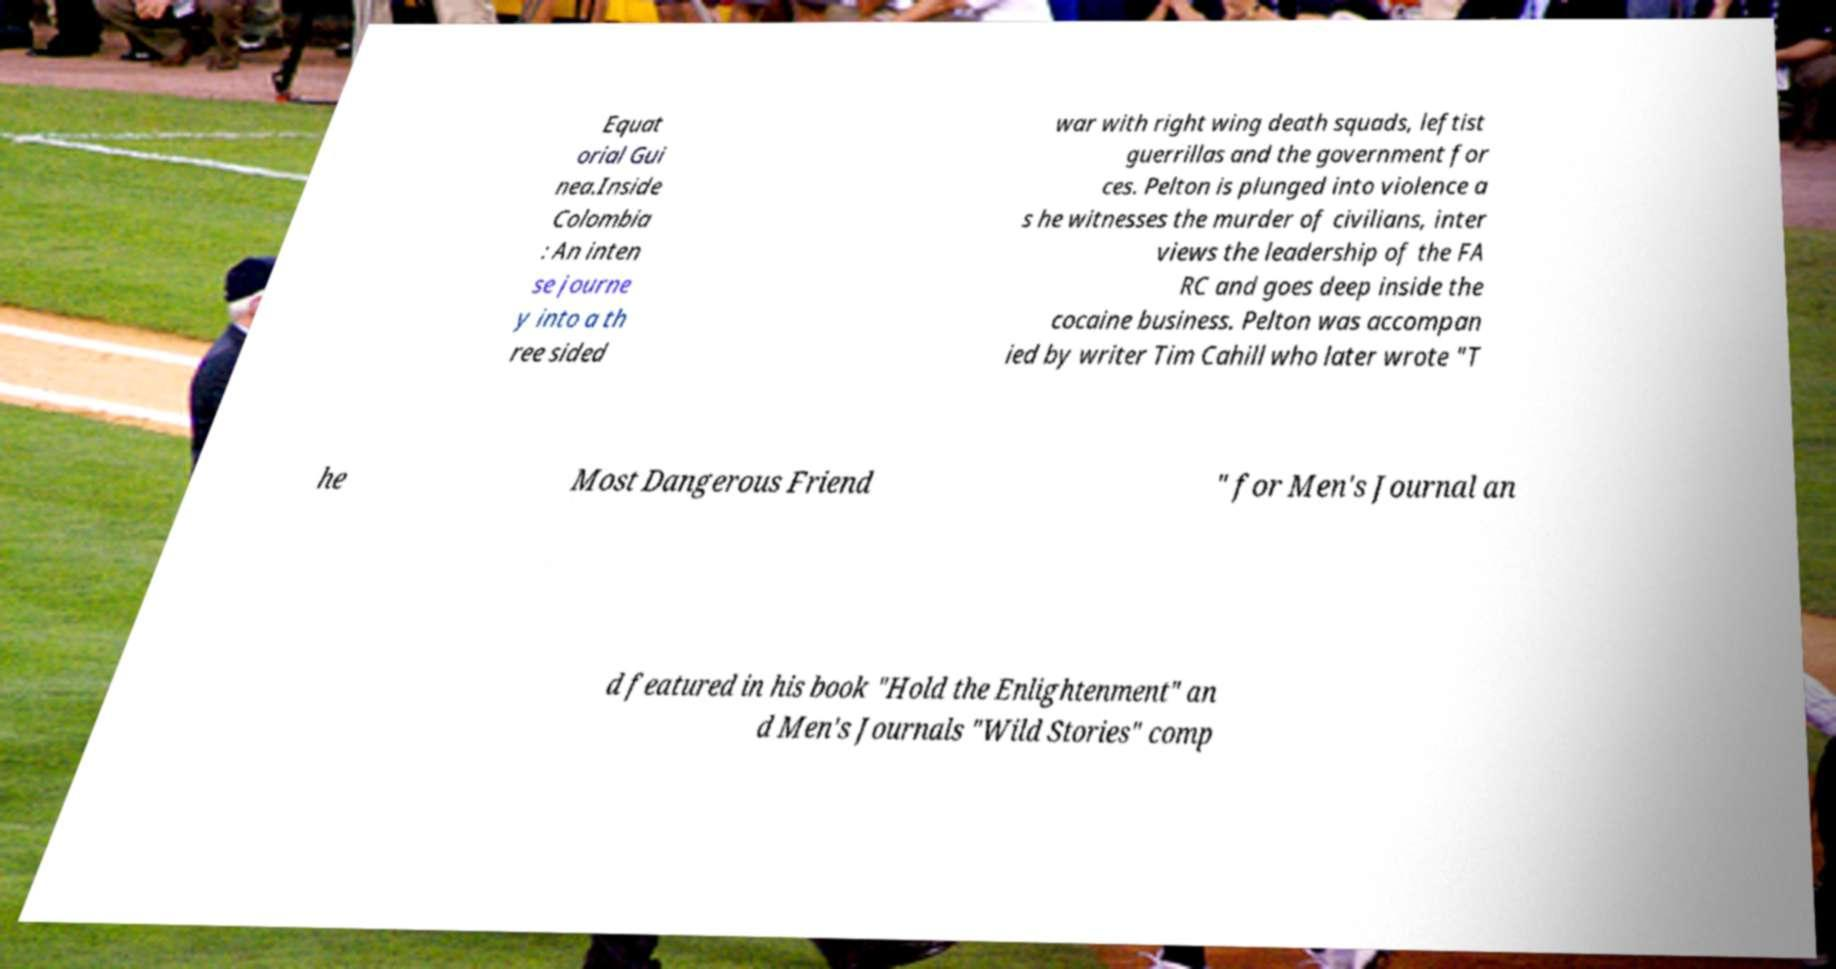Can you accurately transcribe the text from the provided image for me? Equat orial Gui nea.Inside Colombia : An inten se journe y into a th ree sided war with right wing death squads, leftist guerrillas and the government for ces. Pelton is plunged into violence a s he witnesses the murder of civilians, inter views the leadership of the FA RC and goes deep inside the cocaine business. Pelton was accompan ied by writer Tim Cahill who later wrote "T he Most Dangerous Friend " for Men's Journal an d featured in his book "Hold the Enlightenment" an d Men's Journals "Wild Stories" comp 